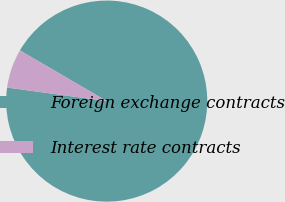Convert chart to OTSL. <chart><loc_0><loc_0><loc_500><loc_500><pie_chart><fcel>Foreign exchange contracts<fcel>Interest rate contracts<nl><fcel>93.74%<fcel>6.26%<nl></chart> 